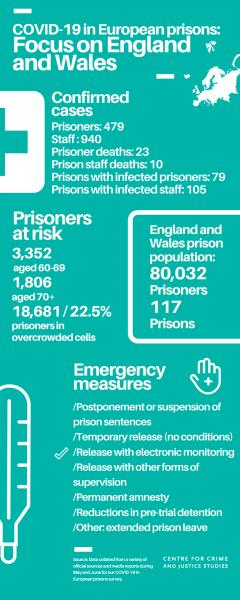Point out several critical features in this image. A report has found that 22.5% of prisoners placed in overcrowded cells in England and Wales are at risk of contracting COVID-19 infections. As of February 24th, 2023, there have been 940 COVID-19 infections reported among prison staff in England and Wales. The number of reported prisoner deaths due to COVID-19 in England and Wales was 23. There are approximately 3,352 prisoners aged 60-69 years who are at risk of contracting COVID-19 infections in England and Wales. There are 117 prisons in England and Wales. 